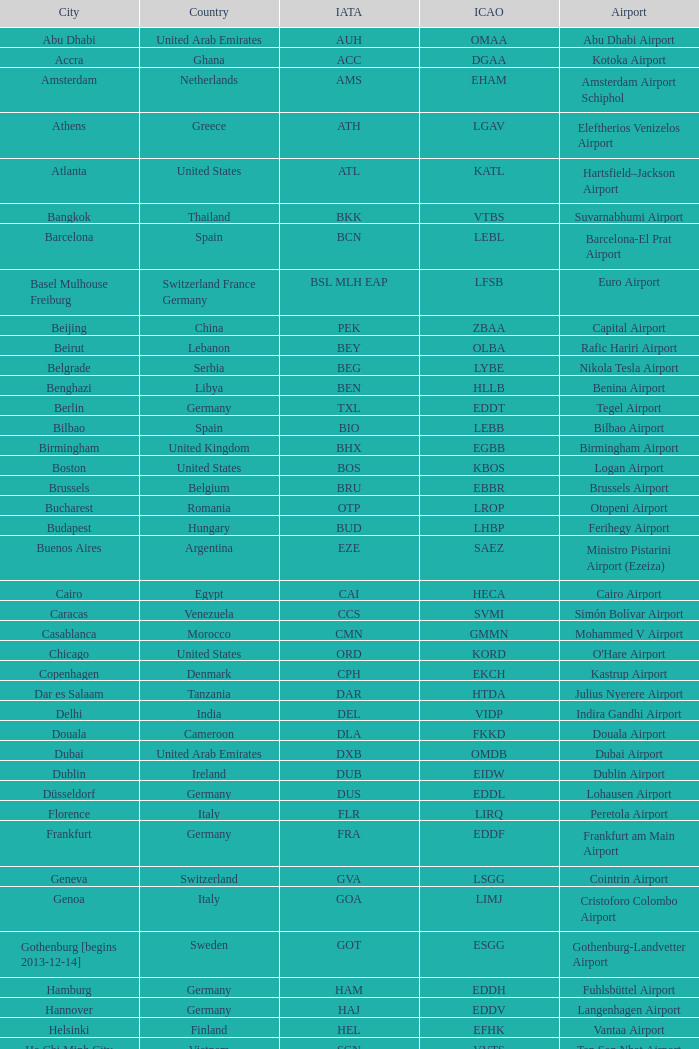Which city has the IATA SSG? Malabo. 